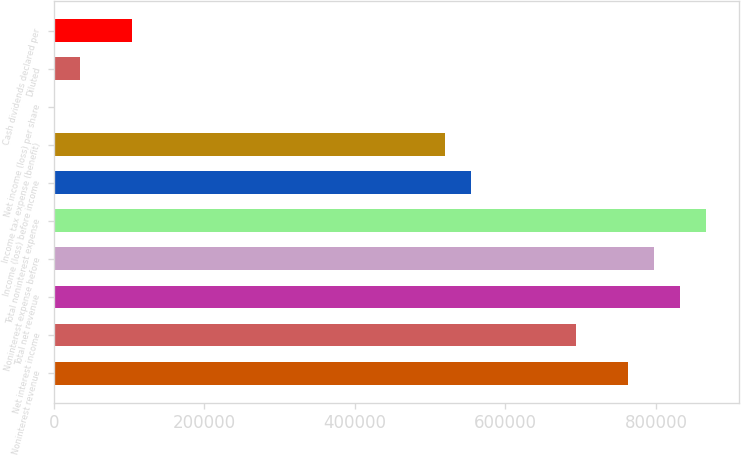<chart> <loc_0><loc_0><loc_500><loc_500><bar_chart><fcel>Noninterest revenue<fcel>Net interest income<fcel>Total net revenue<fcel>Noninterest expense before<fcel>Total noninterest expense<fcel>Income (loss) before income<fcel>Income tax expense (benefit)<fcel>Net income (loss) per share<fcel>Diluted<fcel>Cash dividends declared per<nl><fcel>762385<fcel>693078<fcel>831693<fcel>797039<fcel>866347<fcel>554462<fcel>519808<fcel>0.27<fcel>34654.1<fcel>103962<nl></chart> 